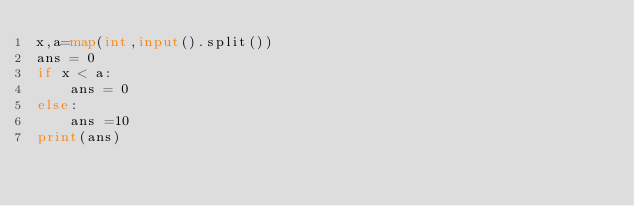<code> <loc_0><loc_0><loc_500><loc_500><_Python_>x,a=map(int,input().split())
ans = 0
if x < a:
    ans = 0
else:
    ans =10
print(ans)
</code> 